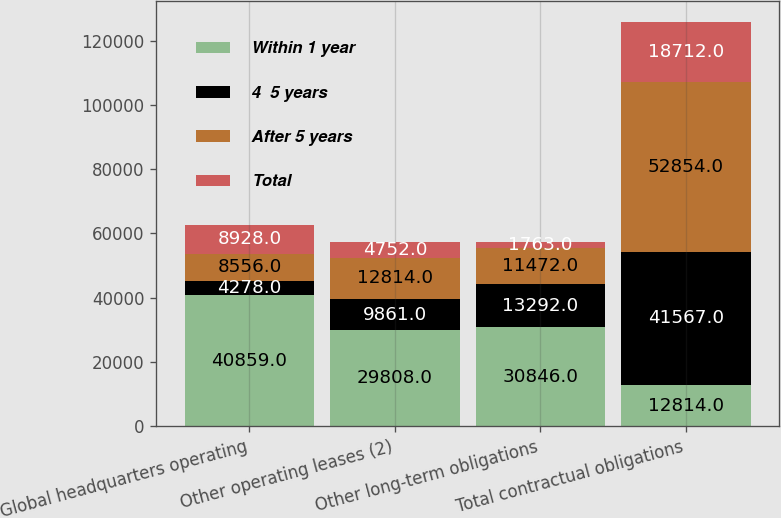Convert chart to OTSL. <chart><loc_0><loc_0><loc_500><loc_500><stacked_bar_chart><ecel><fcel>Global headquarters operating<fcel>Other operating leases (2)<fcel>Other long-term obligations<fcel>Total contractual obligations<nl><fcel>Within 1 year<fcel>40859<fcel>29808<fcel>30846<fcel>12814<nl><fcel>4  5 years<fcel>4278<fcel>9861<fcel>13292<fcel>41567<nl><fcel>After 5 years<fcel>8556<fcel>12814<fcel>11472<fcel>52854<nl><fcel>Total<fcel>8928<fcel>4752<fcel>1763<fcel>18712<nl></chart> 